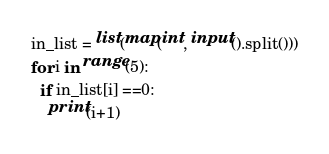<code> <loc_0><loc_0><loc_500><loc_500><_Python_>in_list = list(map(int, input().split()))
for i in range(5):
  if in_list[i] ==0:
    print(i+1)</code> 